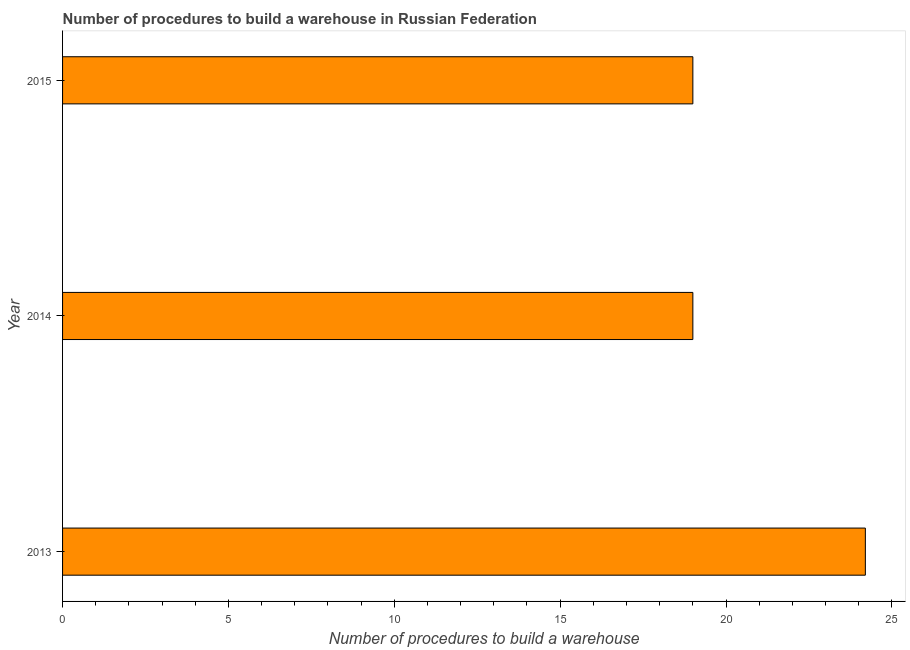Does the graph contain any zero values?
Your answer should be compact. No. Does the graph contain grids?
Give a very brief answer. No. What is the title of the graph?
Your answer should be compact. Number of procedures to build a warehouse in Russian Federation. What is the label or title of the X-axis?
Make the answer very short. Number of procedures to build a warehouse. What is the number of procedures to build a warehouse in 2015?
Ensure brevity in your answer.  19. Across all years, what is the maximum number of procedures to build a warehouse?
Give a very brief answer. 24.2. Across all years, what is the minimum number of procedures to build a warehouse?
Make the answer very short. 19. In which year was the number of procedures to build a warehouse maximum?
Provide a succinct answer. 2013. What is the sum of the number of procedures to build a warehouse?
Give a very brief answer. 62.2. What is the difference between the number of procedures to build a warehouse in 2013 and 2014?
Offer a terse response. 5.2. What is the average number of procedures to build a warehouse per year?
Provide a short and direct response. 20.73. Do a majority of the years between 2014 and 2013 (inclusive) have number of procedures to build a warehouse greater than 12 ?
Your response must be concise. No. What is the ratio of the number of procedures to build a warehouse in 2013 to that in 2015?
Your answer should be very brief. 1.27. What is the difference between the highest and the lowest number of procedures to build a warehouse?
Make the answer very short. 5.2. How many bars are there?
Make the answer very short. 3. Are all the bars in the graph horizontal?
Provide a succinct answer. Yes. How many years are there in the graph?
Offer a very short reply. 3. Are the values on the major ticks of X-axis written in scientific E-notation?
Your response must be concise. No. What is the Number of procedures to build a warehouse of 2013?
Offer a terse response. 24.2. What is the Number of procedures to build a warehouse of 2014?
Your response must be concise. 19. What is the difference between the Number of procedures to build a warehouse in 2013 and 2014?
Provide a succinct answer. 5.2. What is the difference between the Number of procedures to build a warehouse in 2014 and 2015?
Your answer should be very brief. 0. What is the ratio of the Number of procedures to build a warehouse in 2013 to that in 2014?
Provide a succinct answer. 1.27. What is the ratio of the Number of procedures to build a warehouse in 2013 to that in 2015?
Your response must be concise. 1.27. 